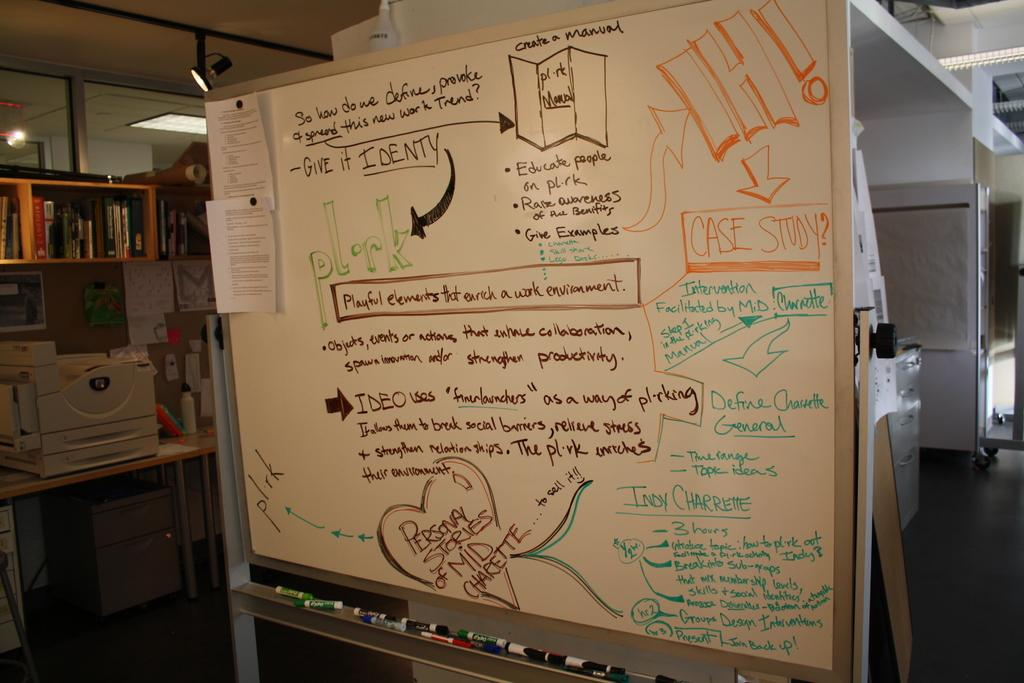Provide a one-sentence caption for the provided image. A white board inside a office area with different colored writing on it and a large IH! written followed by the words case study as there is a description. 